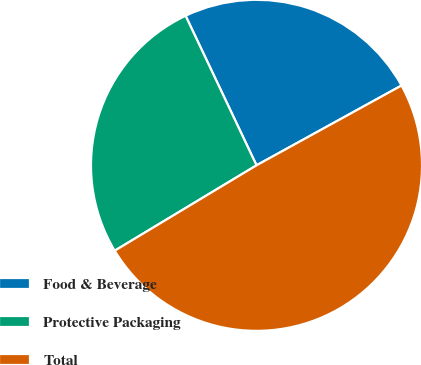Convert chart to OTSL. <chart><loc_0><loc_0><loc_500><loc_500><pie_chart><fcel>Food & Beverage<fcel>Protective Packaging<fcel>Total<nl><fcel>24.04%<fcel>26.58%<fcel>49.38%<nl></chart> 